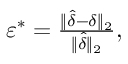<formula> <loc_0><loc_0><loc_500><loc_500>\begin{array} { r } { \varepsilon ^ { * } = \frac { \| \hat { \delta } - \delta \| _ { 2 } } { \| \hat { \delta } \| _ { 2 } } , } \end{array}</formula> 